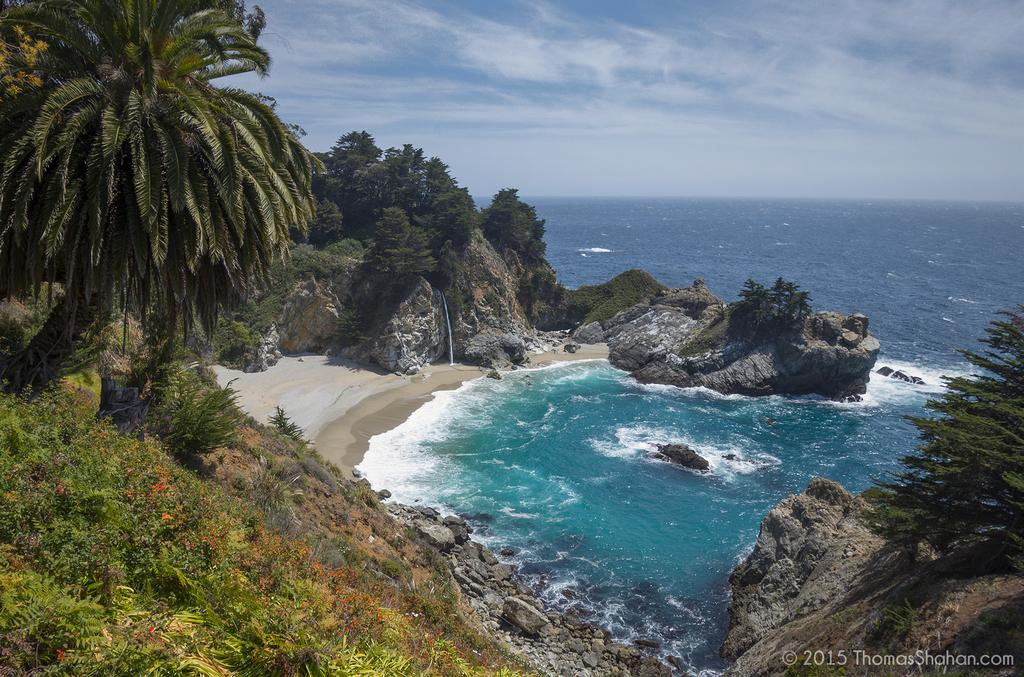What is the condition of the sky in the image? The sky is cloudy in the image. What type of vegetation can be seen in the image? There are plants and trees in the image. What can be seen on the right side of the image? There is water on the right side of the image. Is there any text or logo visible in the image? Yes, there is a watermark in the image. What type of lace can be seen draped over the trees in the image? There is no lace present in the image; it features plants, trees, and water. 